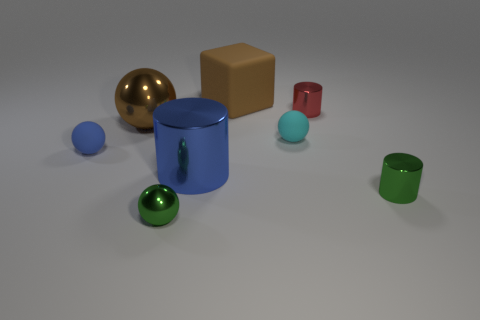What material is the large object that is behind the tiny blue object and to the right of the big ball?
Your answer should be compact. Rubber. The big matte object is what color?
Your response must be concise. Brown. What number of other objects are the same shape as the tiny blue rubber thing?
Keep it short and to the point. 3. Are there an equal number of spheres on the left side of the brown ball and small green cylinders left of the small red metal object?
Ensure brevity in your answer.  No. What is the material of the small green cylinder?
Make the answer very short. Metal. There is a blue object behind the blue shiny cylinder; what is its material?
Provide a short and direct response. Rubber. Is there anything else that is the same material as the small blue sphere?
Keep it short and to the point. Yes. Are there more cyan matte objects that are behind the big matte object than small purple spheres?
Make the answer very short. No. Are there any small green cylinders behind the small green object on the right side of the large brown object on the right side of the big sphere?
Keep it short and to the point. No. There is a cyan rubber object; are there any cyan rubber objects on the right side of it?
Make the answer very short. No. 